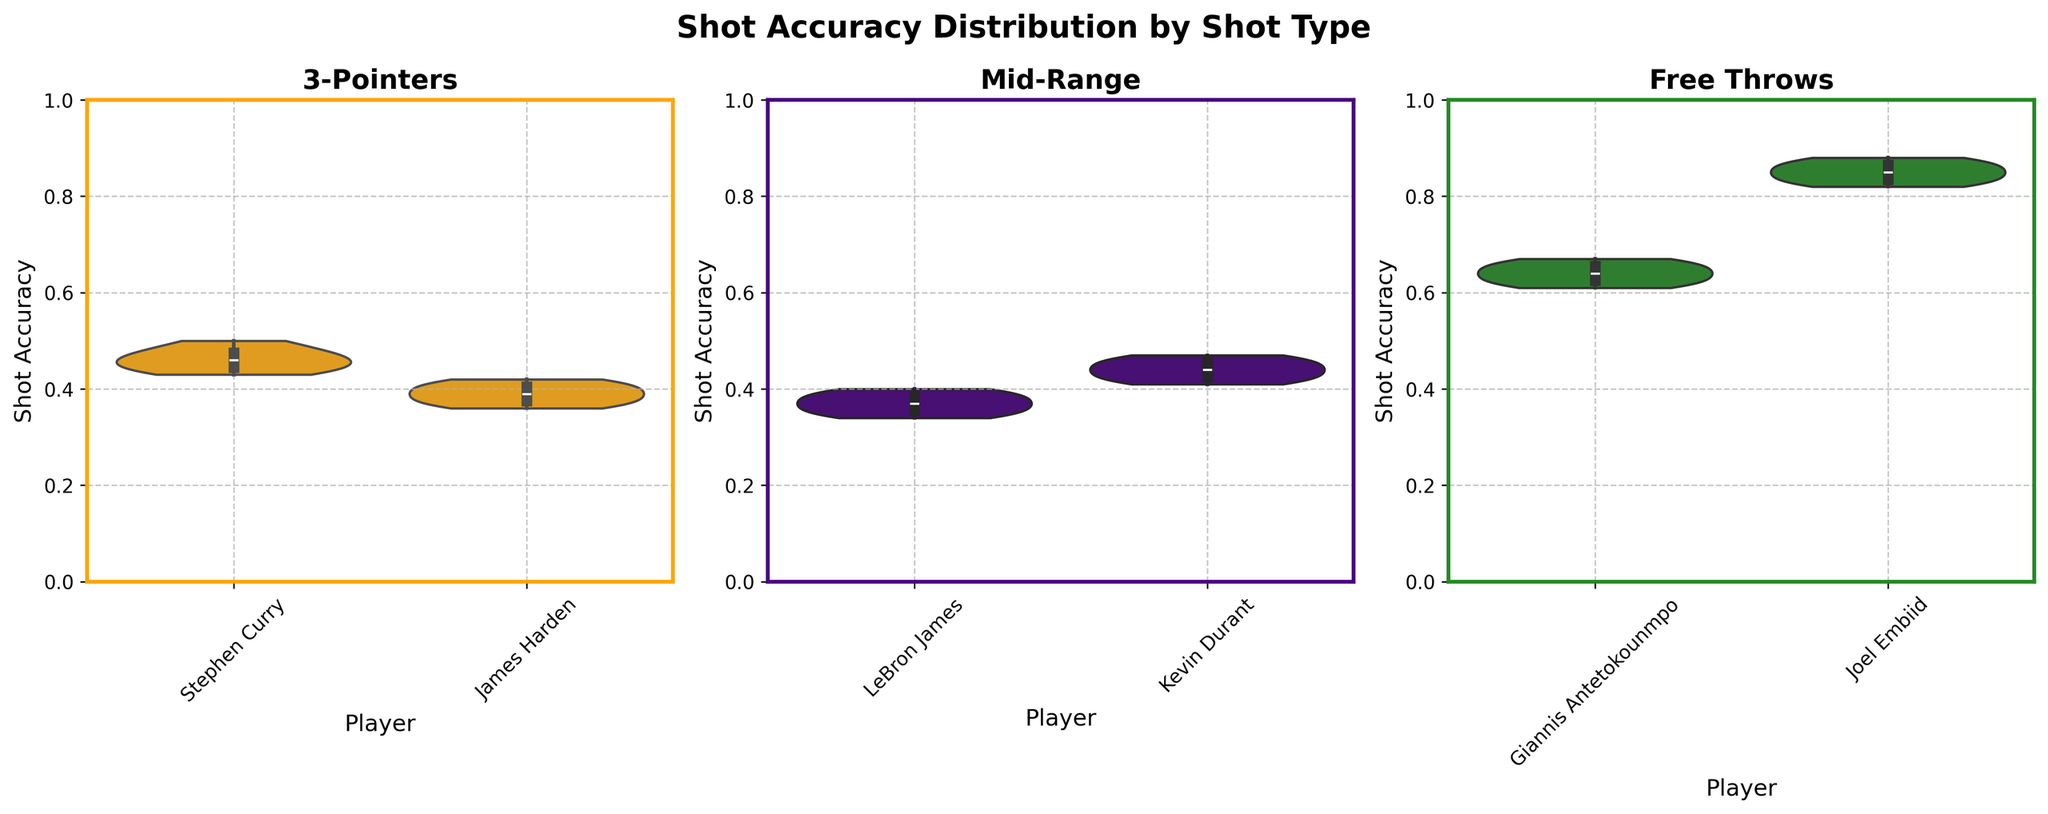What is the title of the figure? The title is displayed at the top of the figure in a larger, bold font.
Answer: Shot Accuracy Distribution by Shot Type Which player has the highest shot accuracy for Free Throws? Joel Embiid's violin plot for Free Throws shows the highest values.
Answer: Joel Embiid Is Stephen Curry's shot accuracy more dispersed or less dispersed than James Harden's for 3-Pointers? Comparing the width of the violin plots for Stephen Curry and James Harden, Stephen Curry's plot is narrower indicating less dispersion.
Answer: Less dispersed What is the range of shot accuracy for LeBron James in Mid-Range shots? The violin plot for LeBron James in Mid-Range shots spans from the lowest to the highest value on the y-axis for Mid-Range shots.
Answer: 0.34 to 0.40 Which shot type shows the highest median value across all players? By looking for the highest position of the box inside the violins, Free Throws have the highest medians.
Answer: Free Throws For which shot type does Kevin Durant have a wider range of shot accuracy? Kevin Durant's violin plot for Mid-Range shots extends across a broader range compared to the others.
Answer: Mid-Range How does Giannis Antetokounmpo's Free Throw accuracy compare to Joel Embiid's? Joel Embiid's violin plot shows consistently higher shot accuracy than Giannis Antetokounmpo's.
Answer: Lower Which player has the lowest shot accuracy for 3-Pointers? James Harden's violin plot for 3-Pointers shows lower overall values.
Answer: James Harden Does any player have shot accuracies that reach or exceed 0.50? Stephen Curry's violin plot for 3-Pointers reaches 0.50.
Answer: Yes, Stephen Curry What's the range of shot accuracy for 3-Pointers by Stephen Curry? The violin plot for Stephen Curry in 3-Pointers ranges from the lowest to the highest point on the y-axis for his shots.
Answer: 0.43 to 0.50 